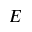Convert formula to latex. <formula><loc_0><loc_0><loc_500><loc_500>E</formula> 